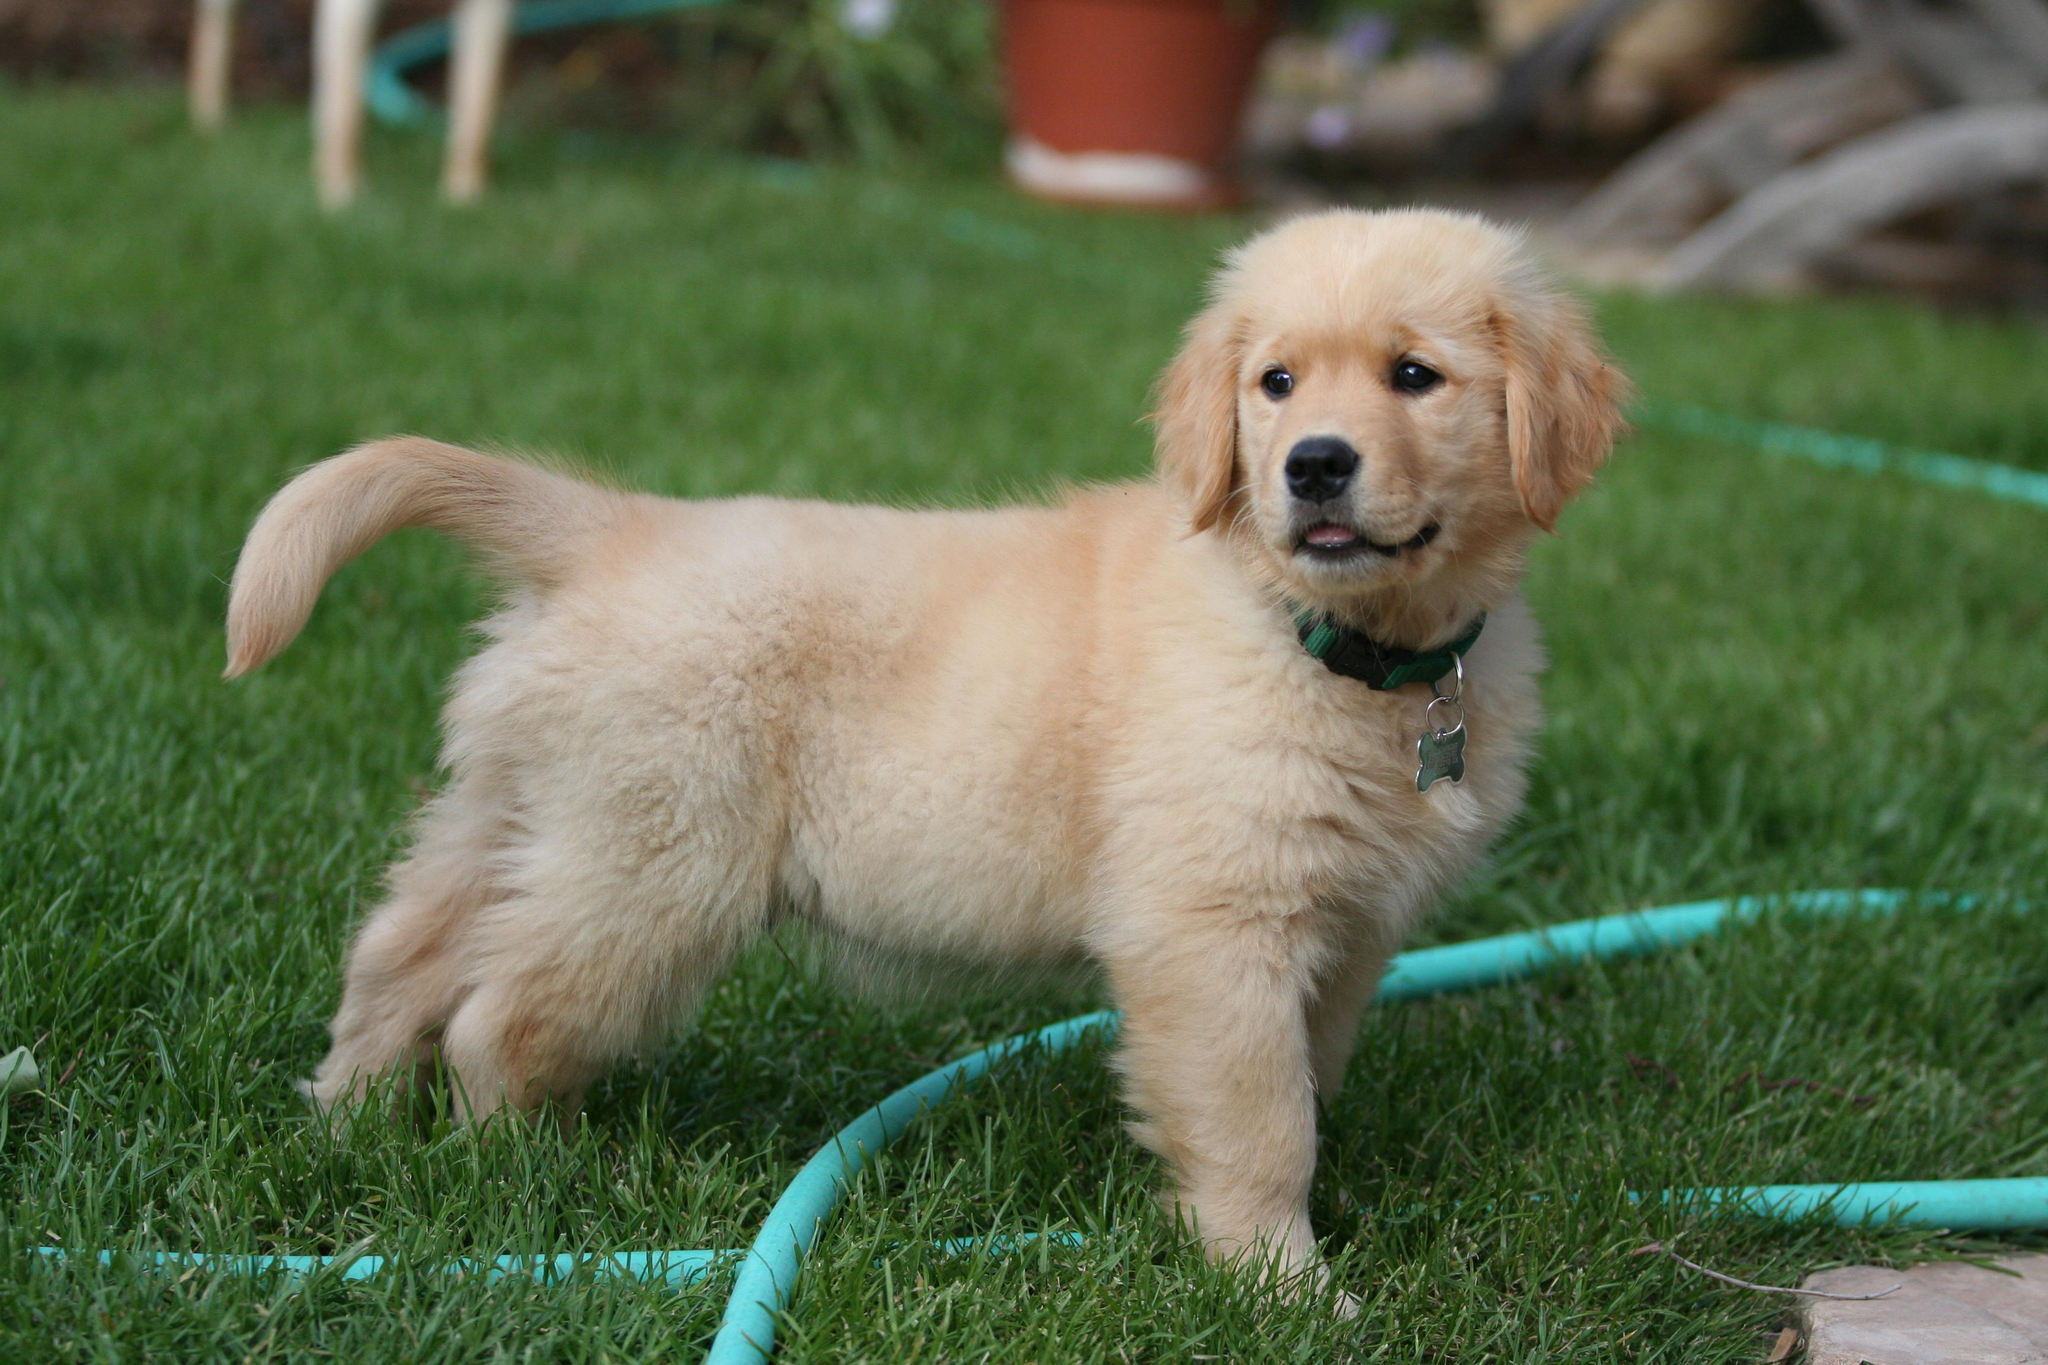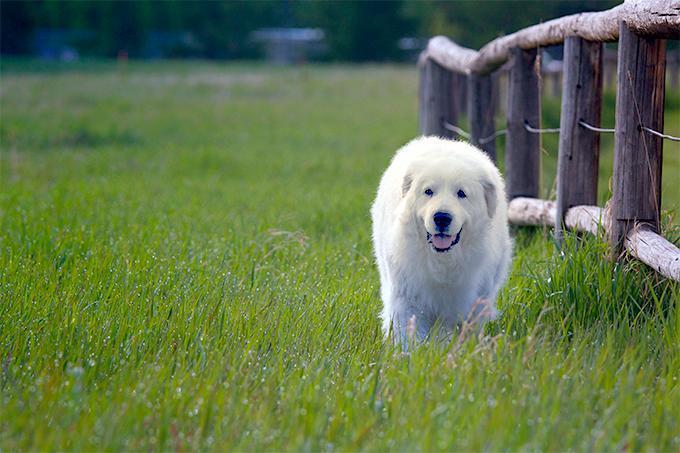The first image is the image on the left, the second image is the image on the right. Considering the images on both sides, is "Left image shows fluffy dog standing on green grass." valid? Answer yes or no. Yes. The first image is the image on the left, the second image is the image on the right. Analyze the images presented: Is the assertion "One of the dogs is standing in a side profile pose." valid? Answer yes or no. Yes. 